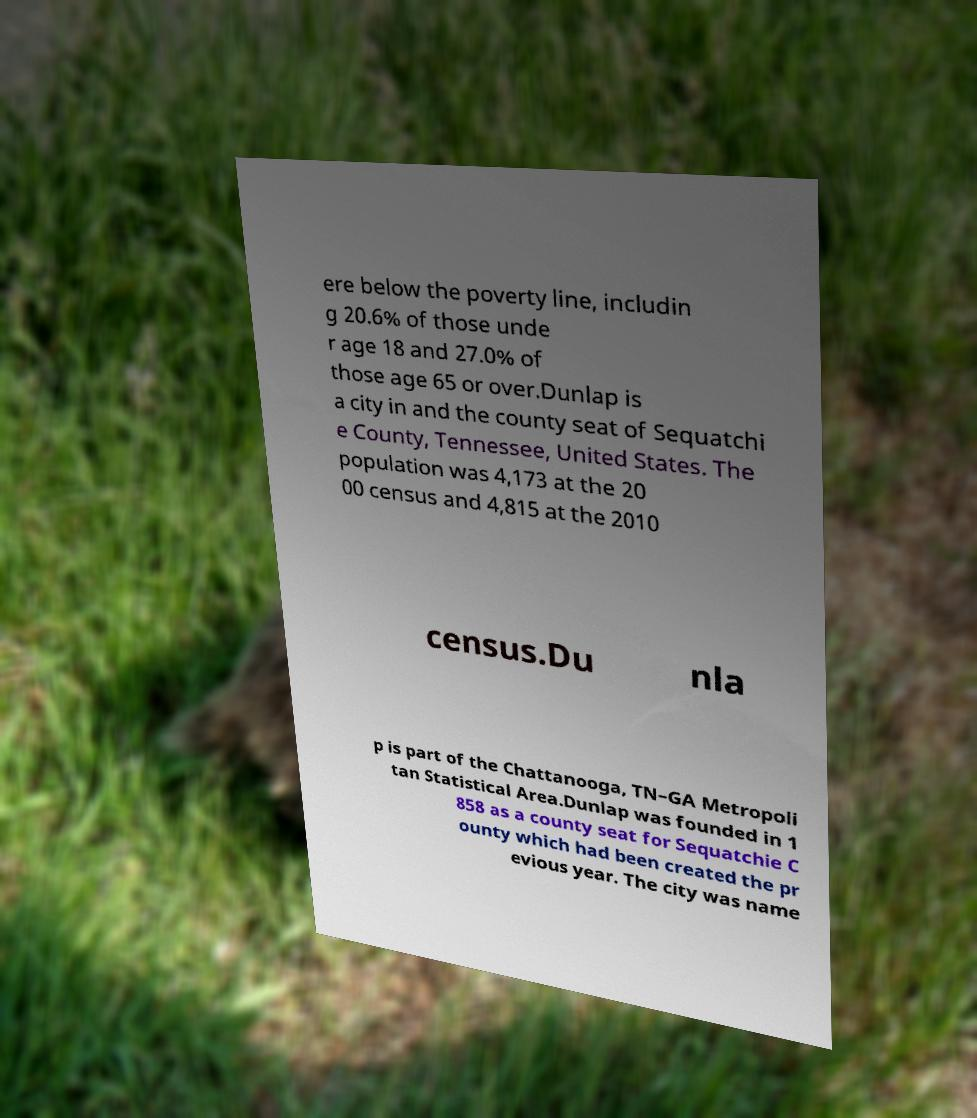Can you read and provide the text displayed in the image?This photo seems to have some interesting text. Can you extract and type it out for me? ere below the poverty line, includin g 20.6% of those unde r age 18 and 27.0% of those age 65 or over.Dunlap is a city in and the county seat of Sequatchi e County, Tennessee, United States. The population was 4,173 at the 20 00 census and 4,815 at the 2010 census.Du nla p is part of the Chattanooga, TN–GA Metropoli tan Statistical Area.Dunlap was founded in 1 858 as a county seat for Sequatchie C ounty which had been created the pr evious year. The city was name 